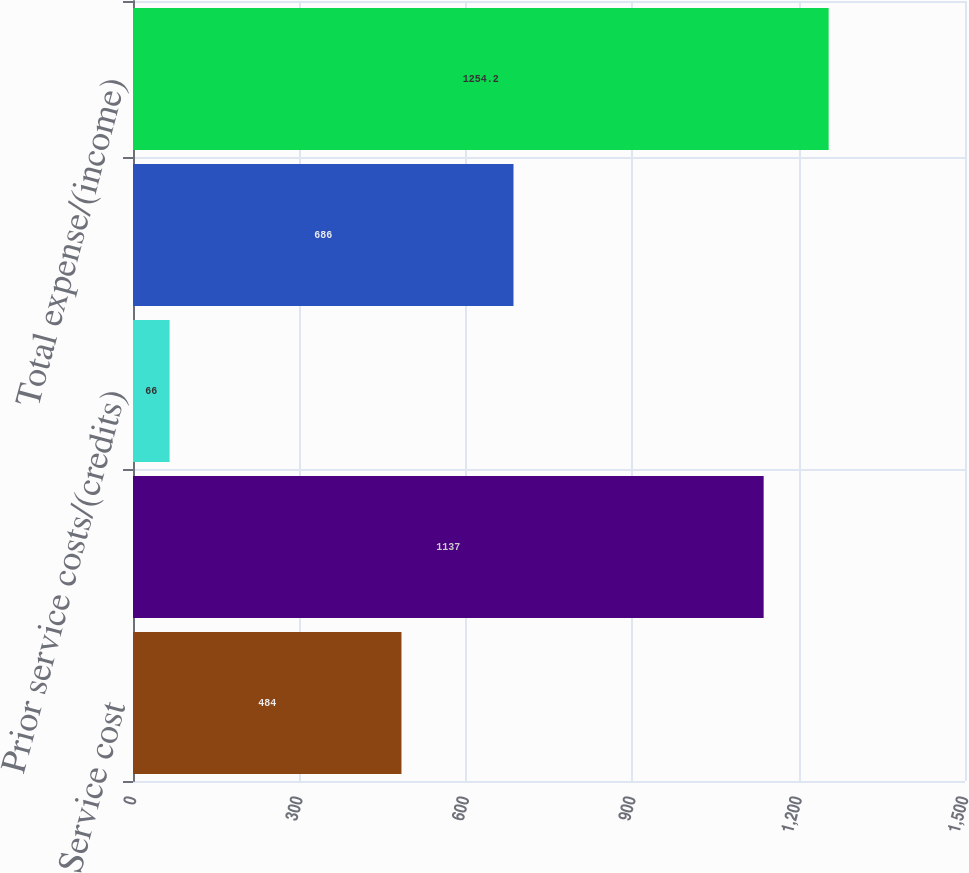Convert chart. <chart><loc_0><loc_0><loc_500><loc_500><bar_chart><fcel>Service cost<fcel>Interest cost<fcel>Prior service costs/(credits)<fcel>(Gains)/Losses<fcel>Total expense/(income)<nl><fcel>484<fcel>1137<fcel>66<fcel>686<fcel>1254.2<nl></chart> 